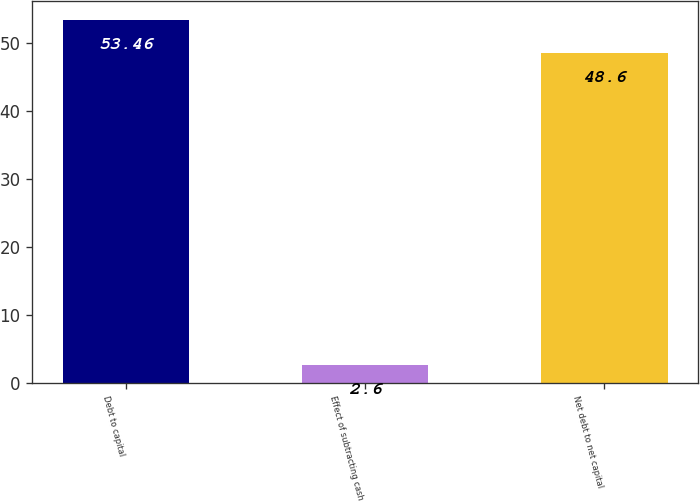Convert chart to OTSL. <chart><loc_0><loc_0><loc_500><loc_500><bar_chart><fcel>Debt to capital<fcel>Effect of subtracting cash<fcel>Net debt to net capital<nl><fcel>53.46<fcel>2.6<fcel>48.6<nl></chart> 